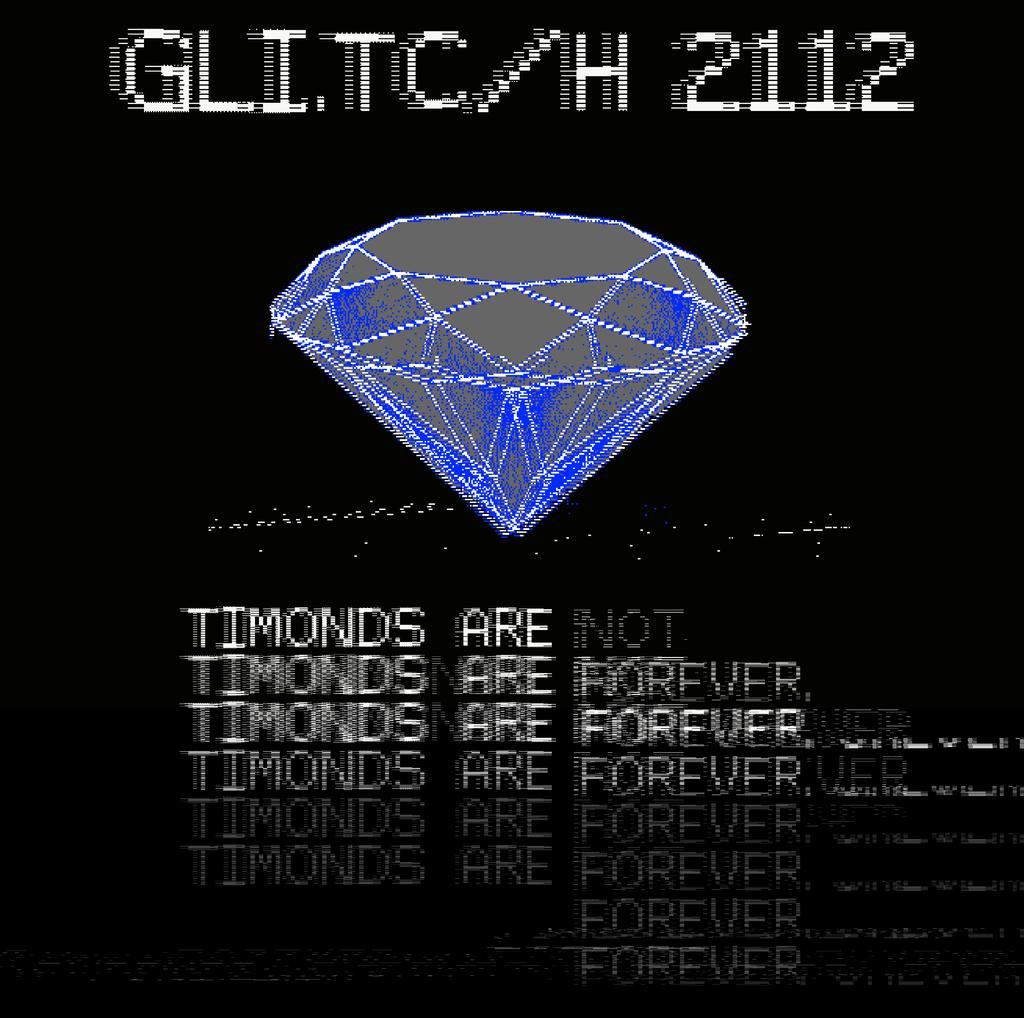<image>
Render a clear and concise summary of the photo. Computer screen of a glitch that diamonds are forever. 